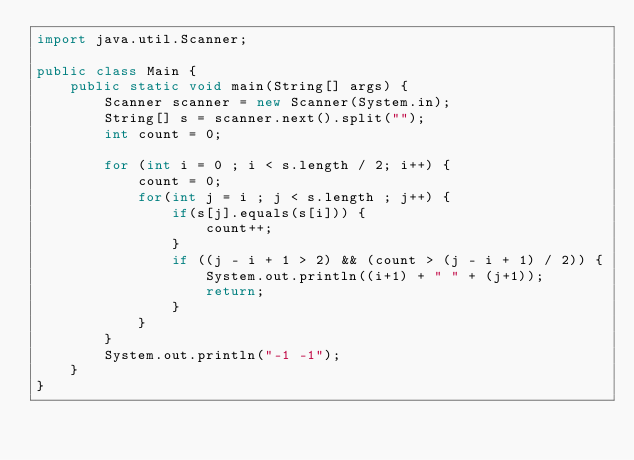Convert code to text. <code><loc_0><loc_0><loc_500><loc_500><_Java_>import java.util.Scanner;

public class Main {
	public static void main(String[] args) {
		Scanner scanner = new Scanner(System.in);
		String[] s = scanner.next().split("");
		int count = 0;

		for (int i = 0 ; i < s.length / 2; i++) {
			count = 0;
			for(int j = i ; j < s.length ; j++) {
				if(s[j].equals(s[i])) {
					count++;
				}
				if ((j - i + 1 > 2) && (count > (j - i + 1) / 2)) {
					System.out.println((i+1) + " " + (j+1));
					return;
				}
			}
		}
		System.out.println("-1 -1");
	}
}
</code> 